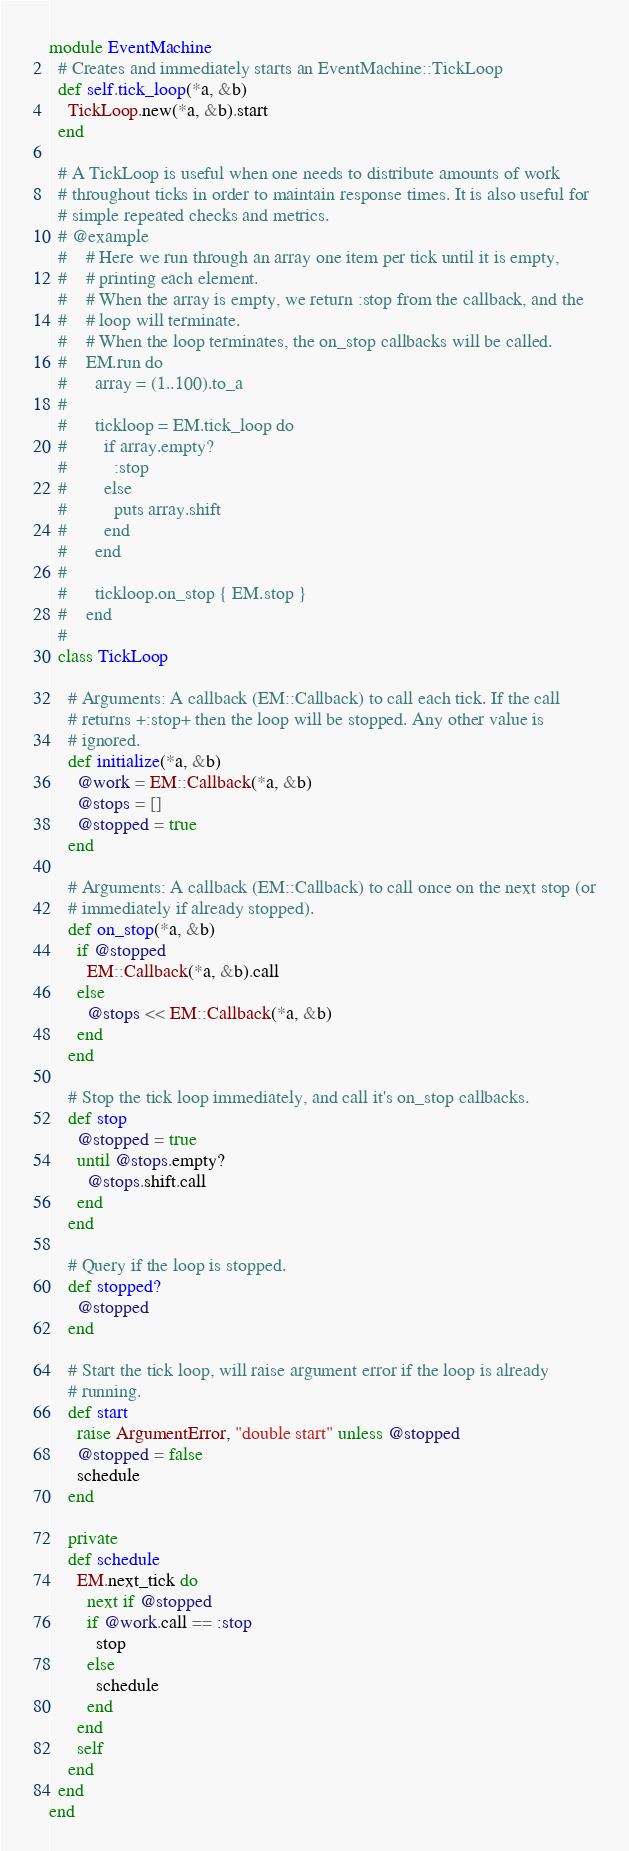Convert code to text. <code><loc_0><loc_0><loc_500><loc_500><_Ruby_>module EventMachine
  # Creates and immediately starts an EventMachine::TickLoop
  def self.tick_loop(*a, &b)
    TickLoop.new(*a, &b).start
  end

  # A TickLoop is useful when one needs to distribute amounts of work
  # throughout ticks in order to maintain response times. It is also useful for
  # simple repeated checks and metrics.
  # @example
  #    # Here we run through an array one item per tick until it is empty, 
  #    # printing each element.
  #    # When the array is empty, we return :stop from the callback, and the
  #    # loop will terminate.
  #    # When the loop terminates, the on_stop callbacks will be called.  
  #    EM.run do
  #      array = (1..100).to_a
  #      
  #      tickloop = EM.tick_loop do
  #        if array.empty?
  #          :stop
  #        else
  #          puts array.shift
  #        end
  #      end
  #      
  #      tickloop.on_stop { EM.stop }
  #    end
  #
  class TickLoop

    # Arguments: A callback (EM::Callback) to call each tick. If the call
    # returns +:stop+ then the loop will be stopped. Any other value is 
    # ignored.
    def initialize(*a, &b)
      @work = EM::Callback(*a, &b)
      @stops = []
      @stopped = true
    end

    # Arguments: A callback (EM::Callback) to call once on the next stop (or
    # immediately if already stopped).
    def on_stop(*a, &b)
      if @stopped
        EM::Callback(*a, &b).call
      else
        @stops << EM::Callback(*a, &b)
      end
    end

    # Stop the tick loop immediately, and call it's on_stop callbacks.
    def stop
      @stopped = true
      until @stops.empty?
        @stops.shift.call
      end
    end

    # Query if the loop is stopped.
    def stopped?
      @stopped
    end

    # Start the tick loop, will raise argument error if the loop is already
    # running.
    def start
      raise ArgumentError, "double start" unless @stopped
      @stopped = false
      schedule
    end

    private
    def schedule
      EM.next_tick do
        next if @stopped
        if @work.call == :stop
          stop
        else
          schedule
        end
      end
      self
    end
  end
end</code> 